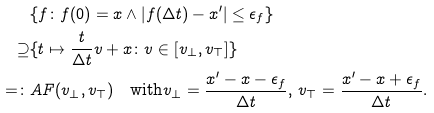<formula> <loc_0><loc_0><loc_500><loc_500>& \{ f \colon f ( 0 ) = x \wedge | f ( \Delta t ) - x ^ { \prime } | \leq \epsilon _ { f } \} \\ \supseteq & \{ t \mapsto \frac { t } { \Delta t } v + x \colon v \in [ v _ { \bot } , v _ { \top } ] \} \\ = \colon & A F ( v _ { \bot } , v _ { \top } ) \quad \text {with} v _ { \bot } = \frac { x ^ { \prime } - x - \epsilon _ { f } } { \Delta t } , \, v _ { \top } = \frac { x ^ { \prime } - x + \epsilon _ { f } } { \Delta t } .</formula> 